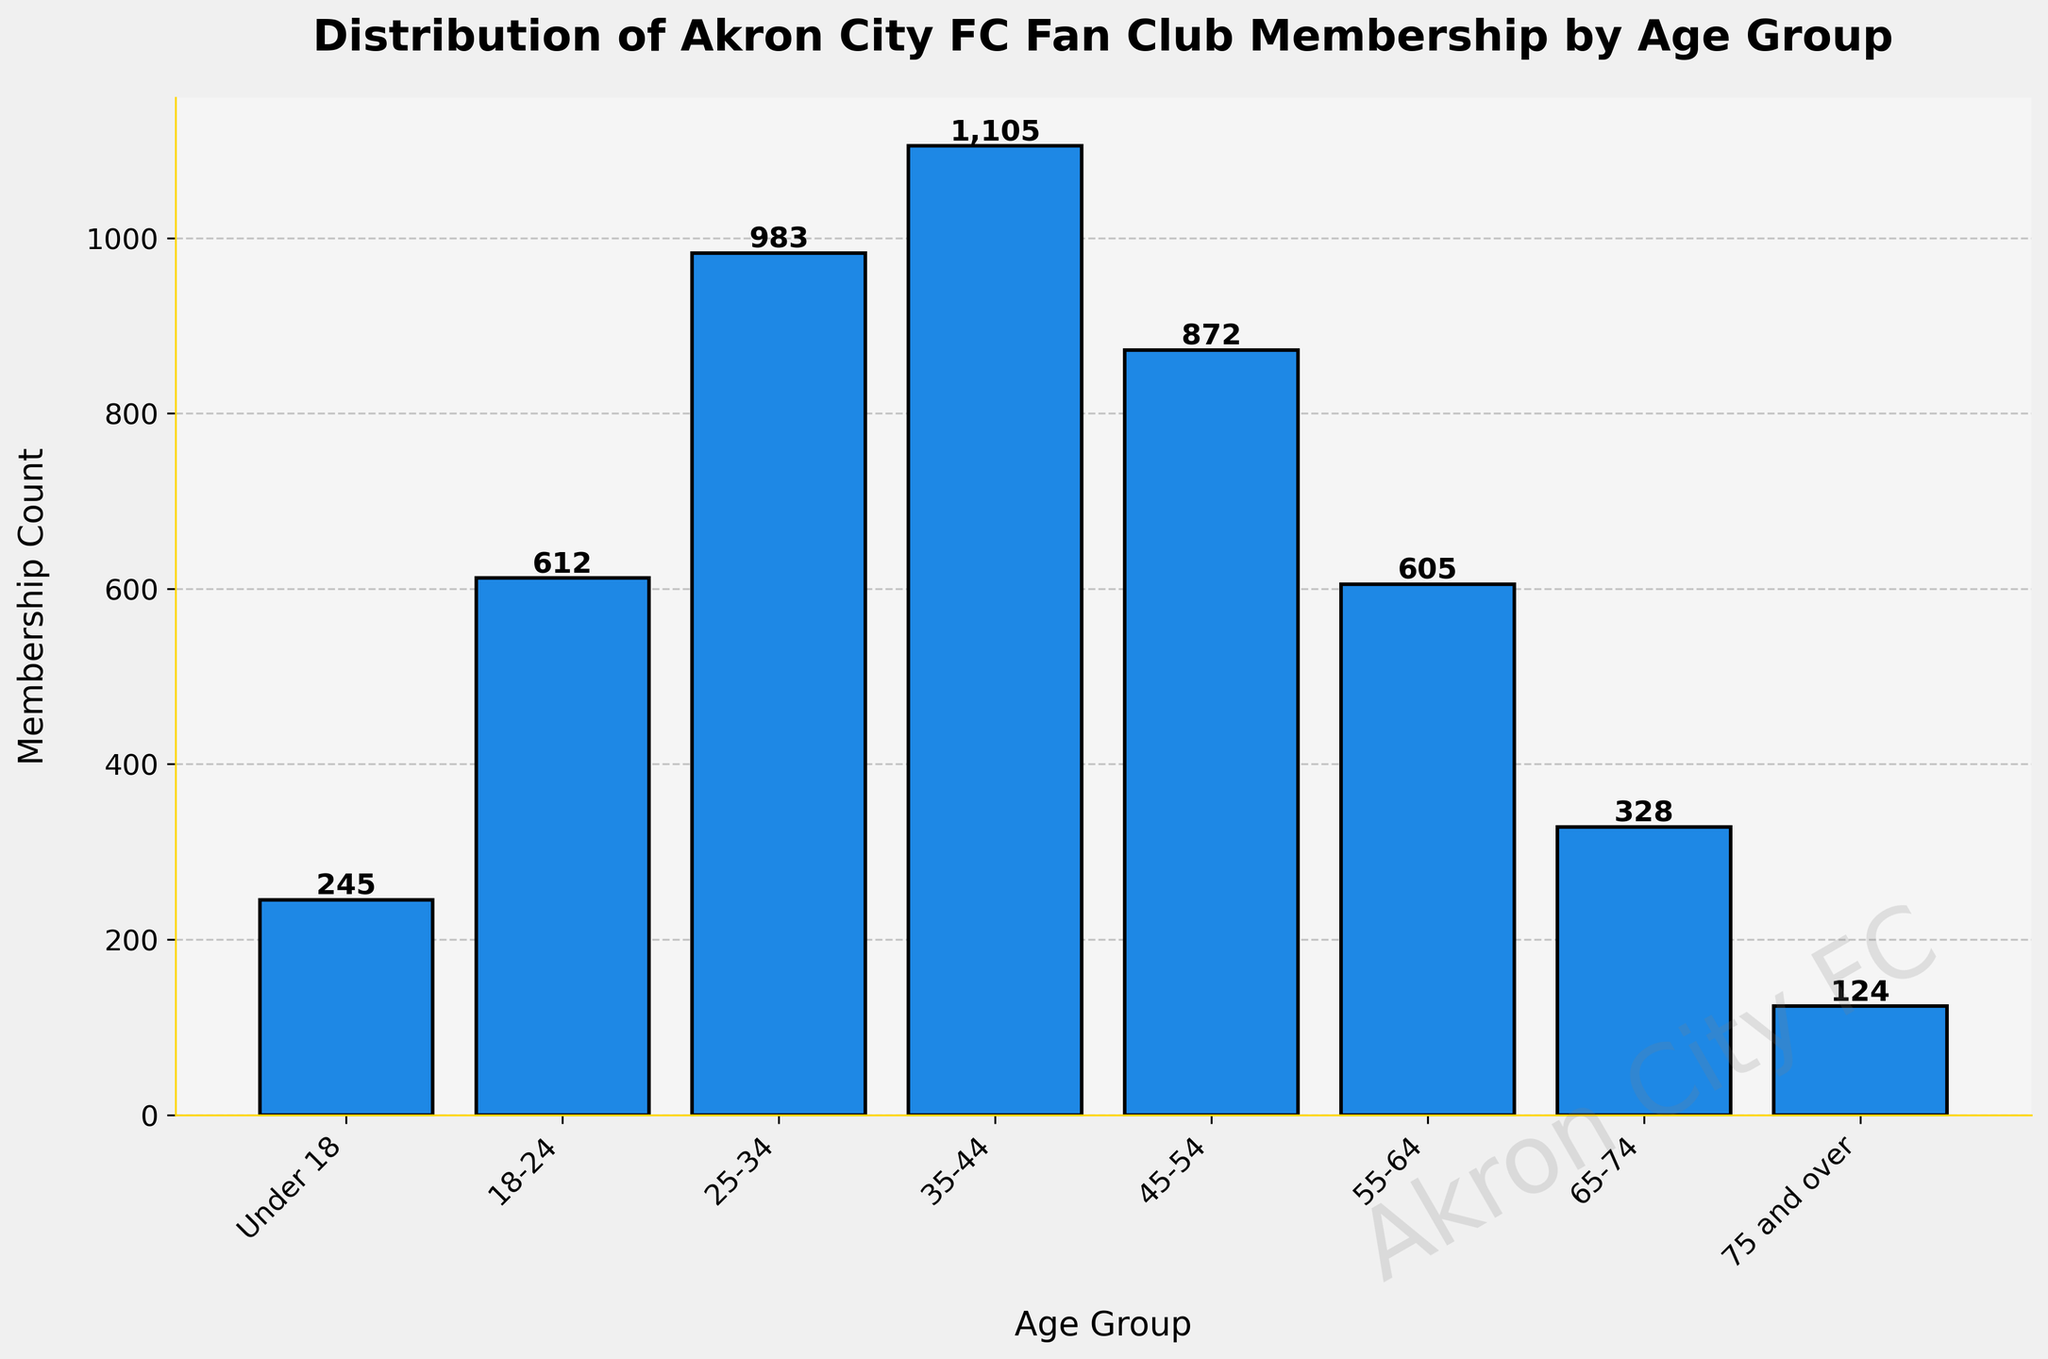What is the age group with the highest membership count? The bar representing 35-44 years old is the tallest, indicating the highest membership count in this age group.
Answer: 35-44 Which age group has fewer members, 18-24 or 55-64? Comparing the heights of the bars for the two age groups, 55-64 years has a shorter bar than 18-24 years.
Answer: 55-64 What is the combined membership count of the two oldest age groups? Adding the membership counts for the 65-74 (328) and 75 and over (124) age groups: 328 + 124 = 452
Answer: 452 How does the membership count for the 25-34 age group compare to that of the 45-54 age group? From the chart, the 45-54 years group (872) has a higher count compared to the 25-34 years group (983).
Answer: Higher What's the difference in membership count between the youngest (Under 18) and the oldest (75 and over) age groups? Subtracting the membership count of the 75 and over group (124) from the Under 18 group (245): 245 - 124 = 121
Answer: 121 Which age group shows a membership count closest to 600? The bar for the 55-64 years group represents a count of 605, which is closest to 600.
Answer: 55-64 What is the sum of membership counts for age groups under 25 years? Adding the counts for Under 18 (245) and 18-24 (612) age groups: 245 + 612 = 857
Answer: 857 What percentage of total membership does the 35-44 age group represent? First, calculate the total membership by summing all age groups (245 + 612 + 983 + 1105 + 872 + 605 + 328 + 124 = 4874), then divide the 35-44 count by the total and multiply by 100: (1105 / 4874) * 100 ≈ 22.68%
Answer: 22.68% 